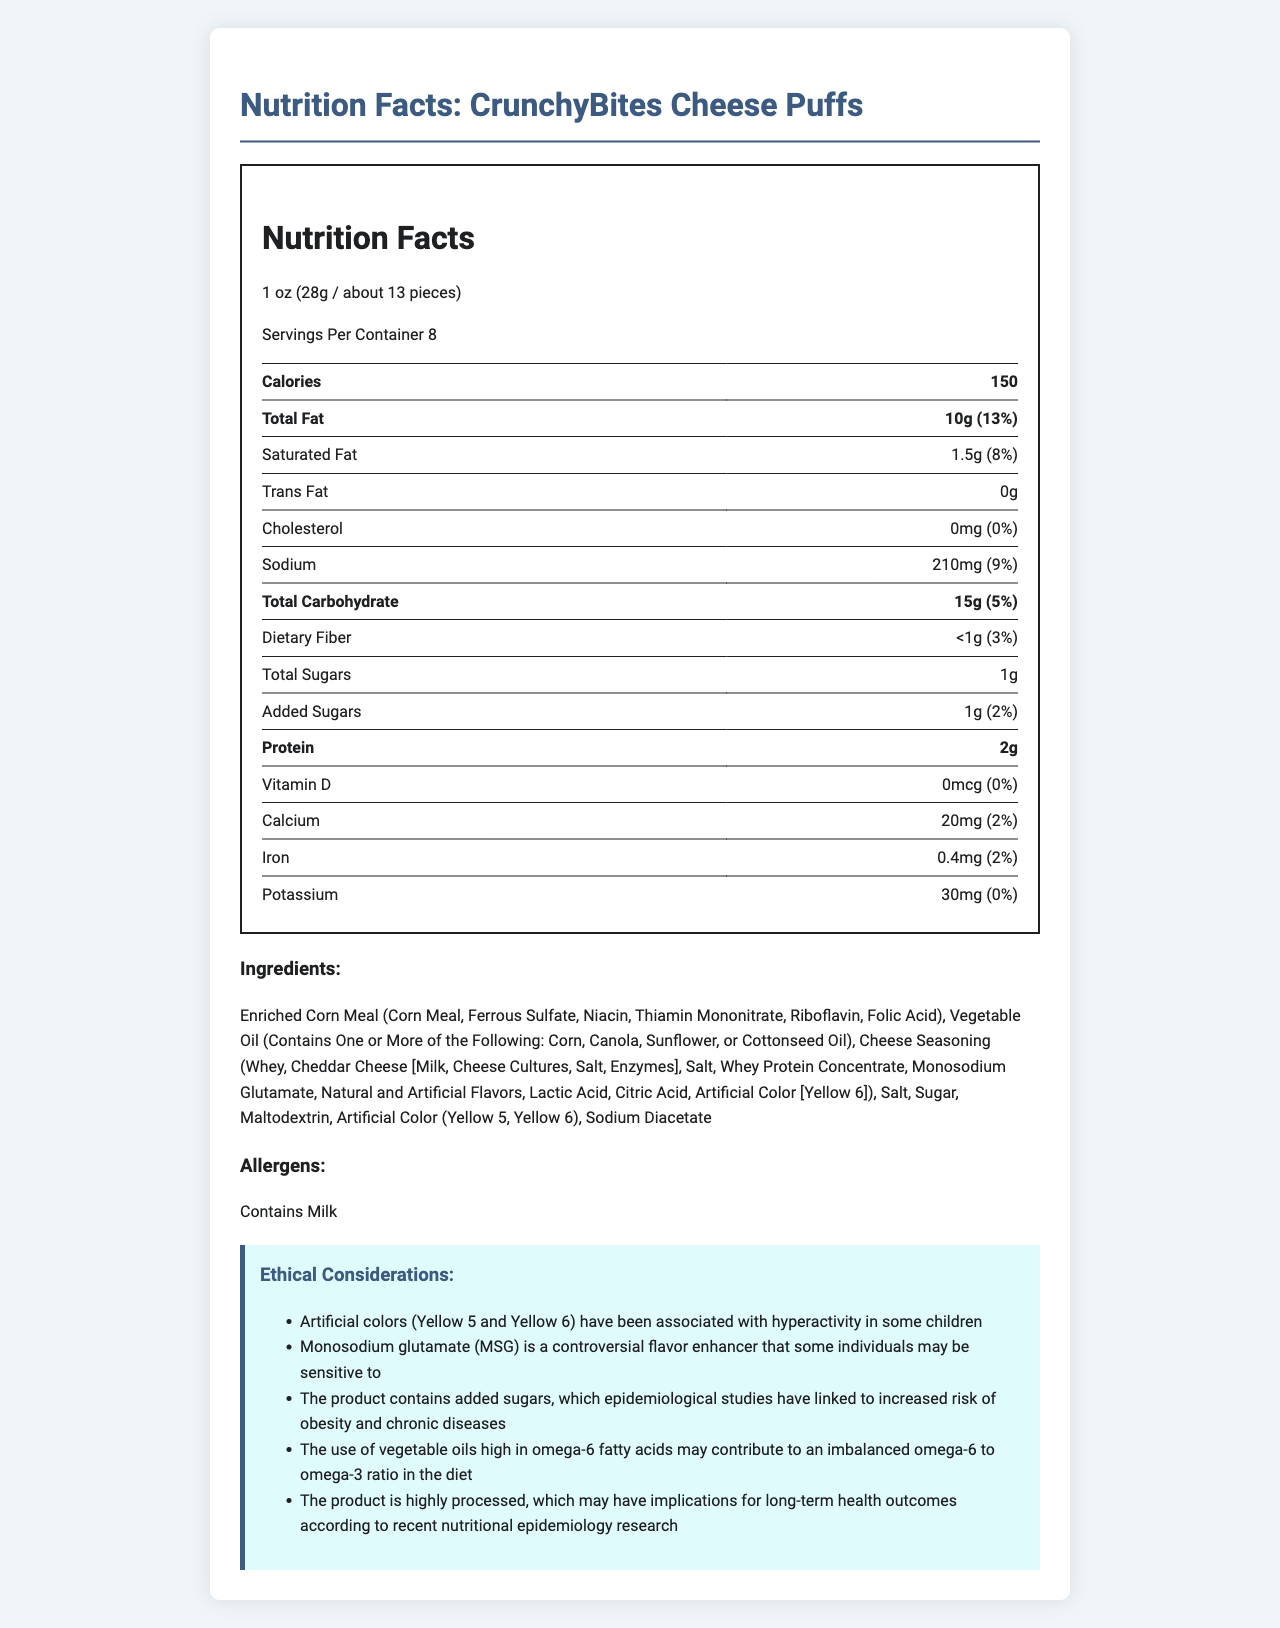What is the serving size for CrunchyBites Cheese Puffs? The serving size is explicitly stated at the top of the nutrition facts label.
Answer: 1 oz (28g / about 13 pieces) How many servings are there per container? The document states “Servings Per Container: 8” near the top of the nutrition label.
Answer: 8 How much protein is in one serving? The amount of protein per serving is clearly listed under the "Protein" section of the nutrition label.
Answer: 2g What is the amount of added sugars per serving? The document lists “Added Sugars” and states the amount as “1g”.
Answer: 1g How much total fat does one serving contain? Under “Total Fat” on the nutrition label, the amount is listed as “10g”.
Answer: 10g Which one of the following allergens is present in this product? A. Soy B. Wheat C. Milk D. Tree Nuts The document lists allergens and states "Contains Milk."
Answer: C. Milk What is the daily value percentage of calcium per serving? A. 0% B. 2% C. 3% D. 5% The document states the daily value for calcium is 2%.
Answer: B. 2% Is there any vitamin D in this product? According to the nutrition facts label, the amount of vitamin D is listed as 0mcg, which is 0% of the daily value.
Answer: No Summarize the main content of the document. The document contains various sections with nutrition facts, ingredients, allergen information, and ethical considerations for CrunchyBites Cheese Puffs. The nutrition facts include calorie count, fat, carbohydrates, protein, vitamins, and minerals with their daily values. Ingredients feature enriched corn meal, vegetable oils, cheese seasoning, and artificial colors. Ethical considerations highlight concerns about additives and health impacts of processed foods.
Answer: The document provides a detailed nutrition facts label for CrunchyBites Cheese Puffs, including information on serving size, calories, macronutrients, vitamins, minerals, and ingredients. It also identifies allergens and lists several ethical considerations related to artificial ingredients and health impacts. What is the primary ingredient in CrunchyBites Cheese Puffs? The list of ingredients begins with "Enriched Corn Meal", indicating it is the primary ingredient.
Answer: Enriched Corn Meal How much sodium is in a single serving? The document lists sodium with an amount of "210mg".
Answer: 210mg True or False: The product contains trans fat. The label shows that trans fat is listed as 0g.
Answer: False Can the exact omega-6 to omega-3 ratio in the product be determined from the document? The document mentions that the use of vegetable oils high in omega-6 fatty acids may contribute to an imbalanced ratio, but it does not provide specific amounts of omega-6 and omega-3 fatty acids.
Answer: Not enough information What artificial colors are used in this product? The ingredients list includes “Artificial Color (Yellow 5, Yellow 6)”.
Answer: Yellow 5, Yellow 6 What controversial ingredient is included in the cheese seasoning? The ingredient list for cheese seasoning mentions "Monosodium Glutamate (MSG)", which is noted to be controversial.
Answer: Monosodium Glutamate (MSG) 